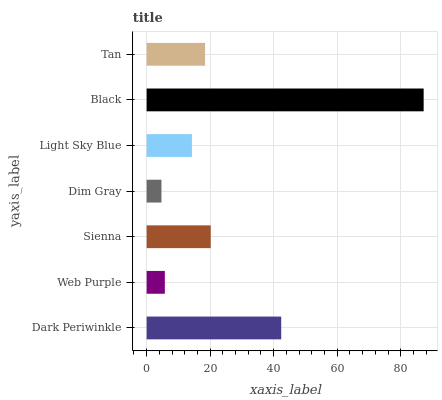Is Dim Gray the minimum?
Answer yes or no. Yes. Is Black the maximum?
Answer yes or no. Yes. Is Web Purple the minimum?
Answer yes or no. No. Is Web Purple the maximum?
Answer yes or no. No. Is Dark Periwinkle greater than Web Purple?
Answer yes or no. Yes. Is Web Purple less than Dark Periwinkle?
Answer yes or no. Yes. Is Web Purple greater than Dark Periwinkle?
Answer yes or no. No. Is Dark Periwinkle less than Web Purple?
Answer yes or no. No. Is Tan the high median?
Answer yes or no. Yes. Is Tan the low median?
Answer yes or no. Yes. Is Sienna the high median?
Answer yes or no. No. Is Dim Gray the low median?
Answer yes or no. No. 